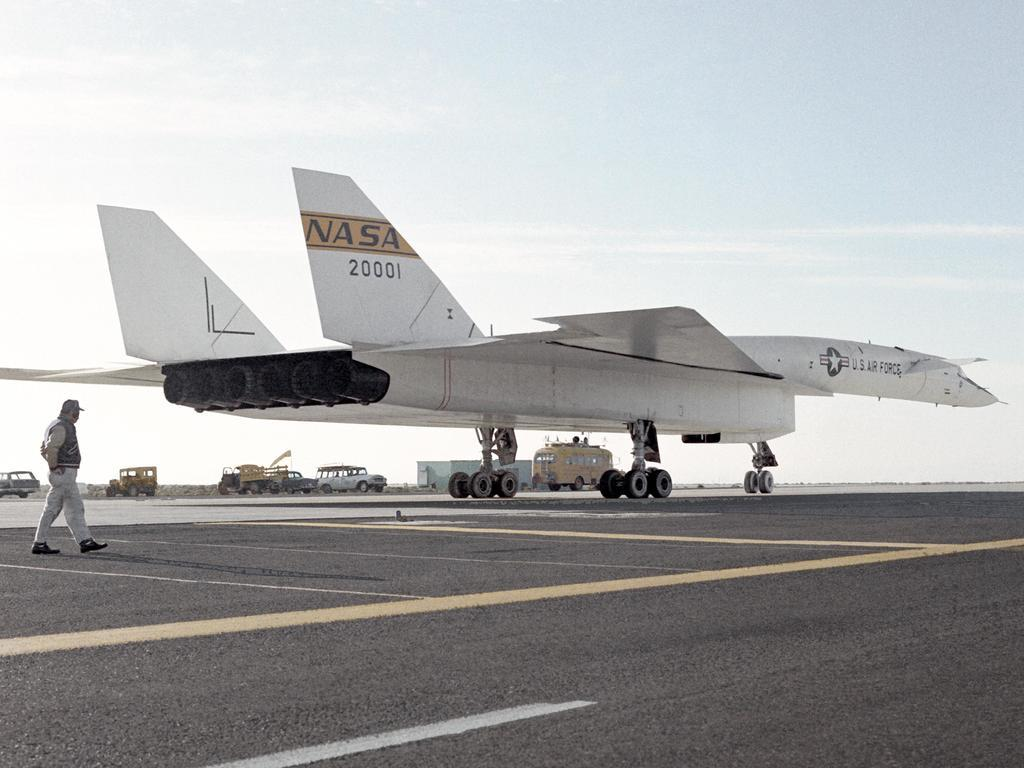What is the color of the airplane in the image? The airplane in the image is white. What is located at the bottom of the image? There is a road at the bottom of the image. Can you describe the person in the image? There is a man standing to the left of the image. What can be seen in the background of the image? There are many vehicles visible in the background of the image. What is the degree of the impulse that the stream has in the image? There is no stream or impulse present in the image. 